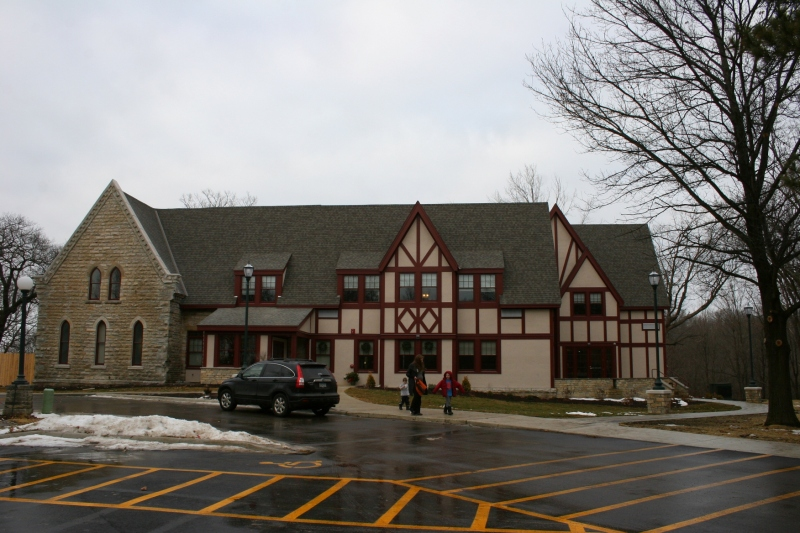Can you tell me what the different architectural styles in this building suggest about its history? This building displays a combination of Gothic Revival elements, seen in the pointed arch windows of the stone section, and Tudor style as evident in the timber framing. This architectural fusion often indicates a building with a long history, likely starting as a singular-style structure that was expanded or modified with additional elements over time. These styles suggest its possible uses over different eras, possibly transitioning from a purely ecclesiastical or institutional building to one serving broader community functions. 